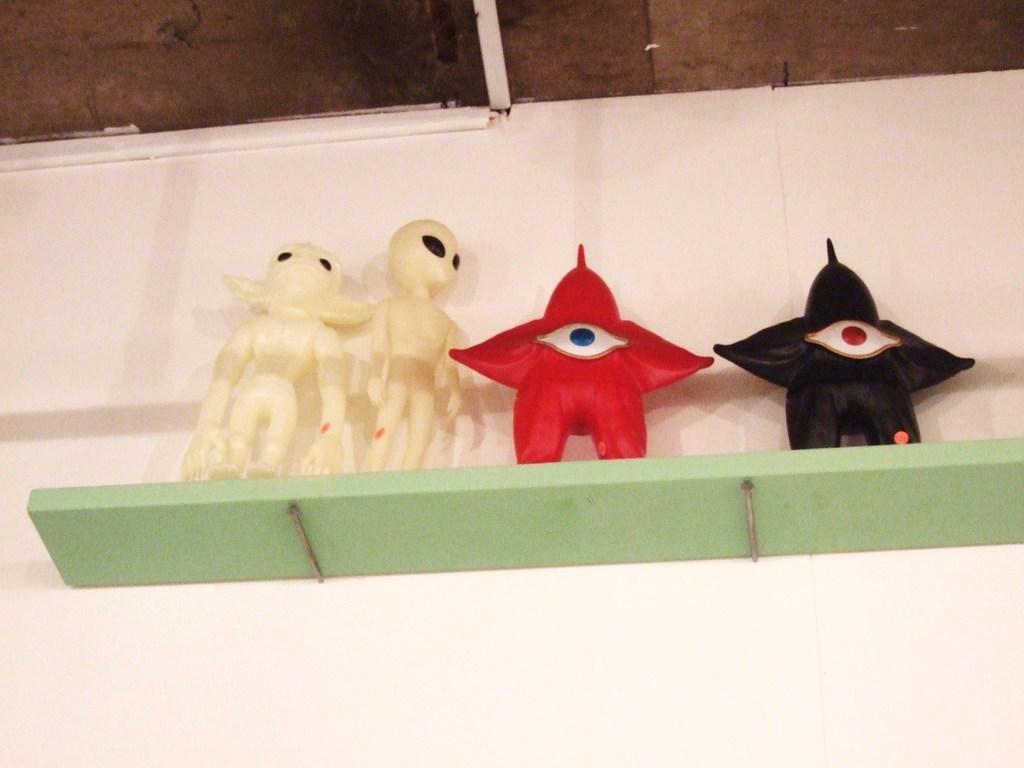Describe this image in one or two sentences. In this picture we can see toys on shelf and we can see wall. 